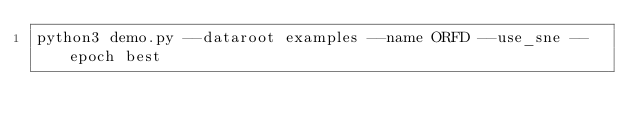Convert code to text. <code><loc_0><loc_0><loc_500><loc_500><_Bash_>python3 demo.py --dataroot examples --name ORFD --use_sne --epoch best
</code> 